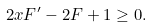Convert formula to latex. <formula><loc_0><loc_0><loc_500><loc_500>2 x F ^ { \prime } - 2 F + 1 \geq 0 .</formula> 